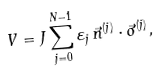<formula> <loc_0><loc_0><loc_500><loc_500>V = J \sum _ { j = 0 } ^ { N - 1 } \varepsilon _ { j } \, \vec { n } ^ { ( j ) } \cdot \vec { \sigma } ^ { ( j ) } ,</formula> 